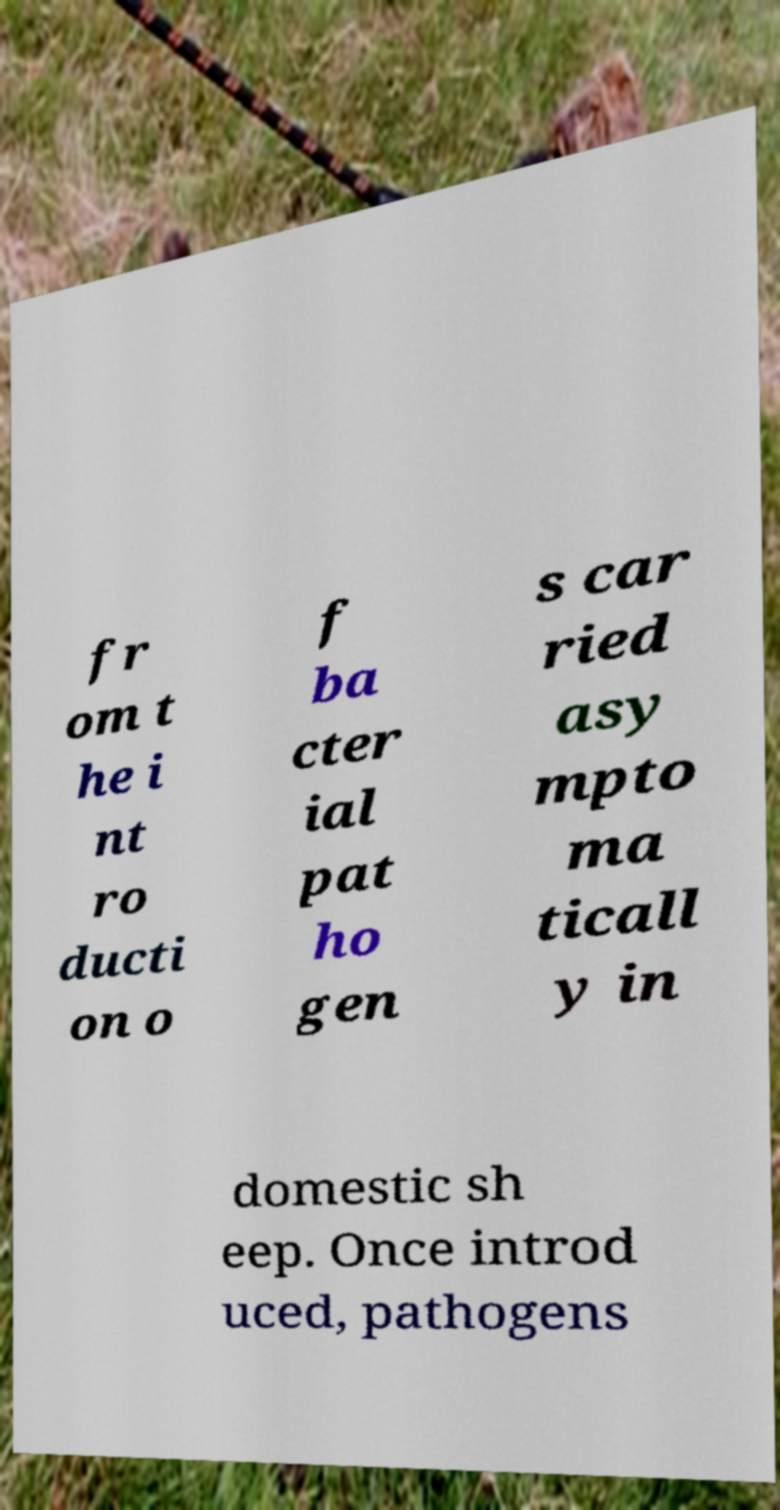Please read and relay the text visible in this image. What does it say? fr om t he i nt ro ducti on o f ba cter ial pat ho gen s car ried asy mpto ma ticall y in domestic sh eep. Once introd uced, pathogens 